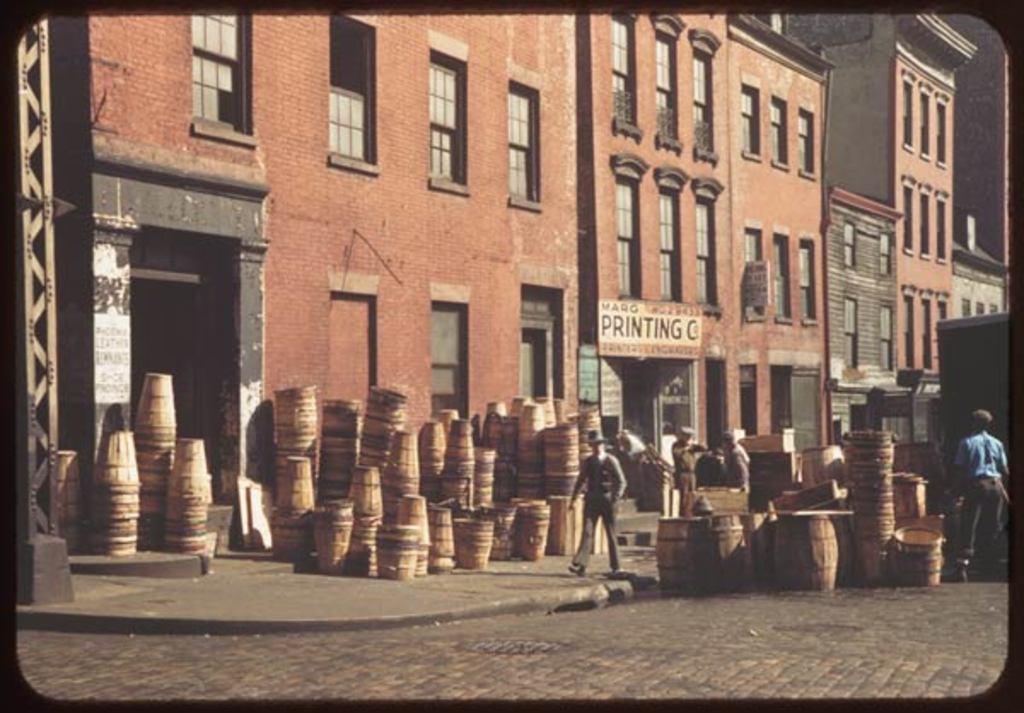Please provide a concise description of this image. In this image I can see the road, the sidewalk and wooden objects which are brown in color on the ground. I can see few persons standing, few buildings which are brown in color, few windows of the building and a board. 